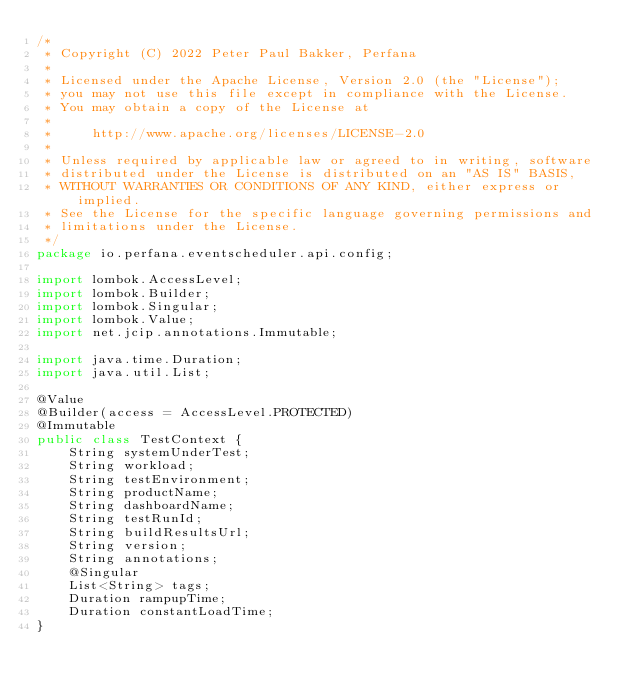Convert code to text. <code><loc_0><loc_0><loc_500><loc_500><_Java_>/*
 * Copyright (C) 2022 Peter Paul Bakker, Perfana
 *
 * Licensed under the Apache License, Version 2.0 (the "License");
 * you may not use this file except in compliance with the License.
 * You may obtain a copy of the License at
 *
 *     http://www.apache.org/licenses/LICENSE-2.0
 *
 * Unless required by applicable law or agreed to in writing, software
 * distributed under the License is distributed on an "AS IS" BASIS,
 * WITHOUT WARRANTIES OR CONDITIONS OF ANY KIND, either express or implied.
 * See the License for the specific language governing permissions and
 * limitations under the License.
 */
package io.perfana.eventscheduler.api.config;

import lombok.AccessLevel;
import lombok.Builder;
import lombok.Singular;
import lombok.Value;
import net.jcip.annotations.Immutable;

import java.time.Duration;
import java.util.List;

@Value
@Builder(access = AccessLevel.PROTECTED)
@Immutable
public class TestContext {
    String systemUnderTest;
    String workload;
    String testEnvironment;
    String productName;
    String dashboardName;
    String testRunId;
    String buildResultsUrl;
    String version;
    String annotations;
    @Singular
    List<String> tags;
    Duration rampupTime;
    Duration constantLoadTime;
}
</code> 